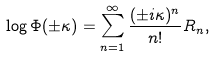<formula> <loc_0><loc_0><loc_500><loc_500>\log \Phi ( \pm \kappa ) = \sum _ { n = 1 } ^ { \infty } \frac { ( \pm i \kappa ) ^ { n } } { n ! } R _ { n } ,</formula> 